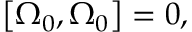<formula> <loc_0><loc_0><loc_500><loc_500>\left [ \Omega _ { 0 } , \Omega _ { 0 } \right ] = 0 ,</formula> 